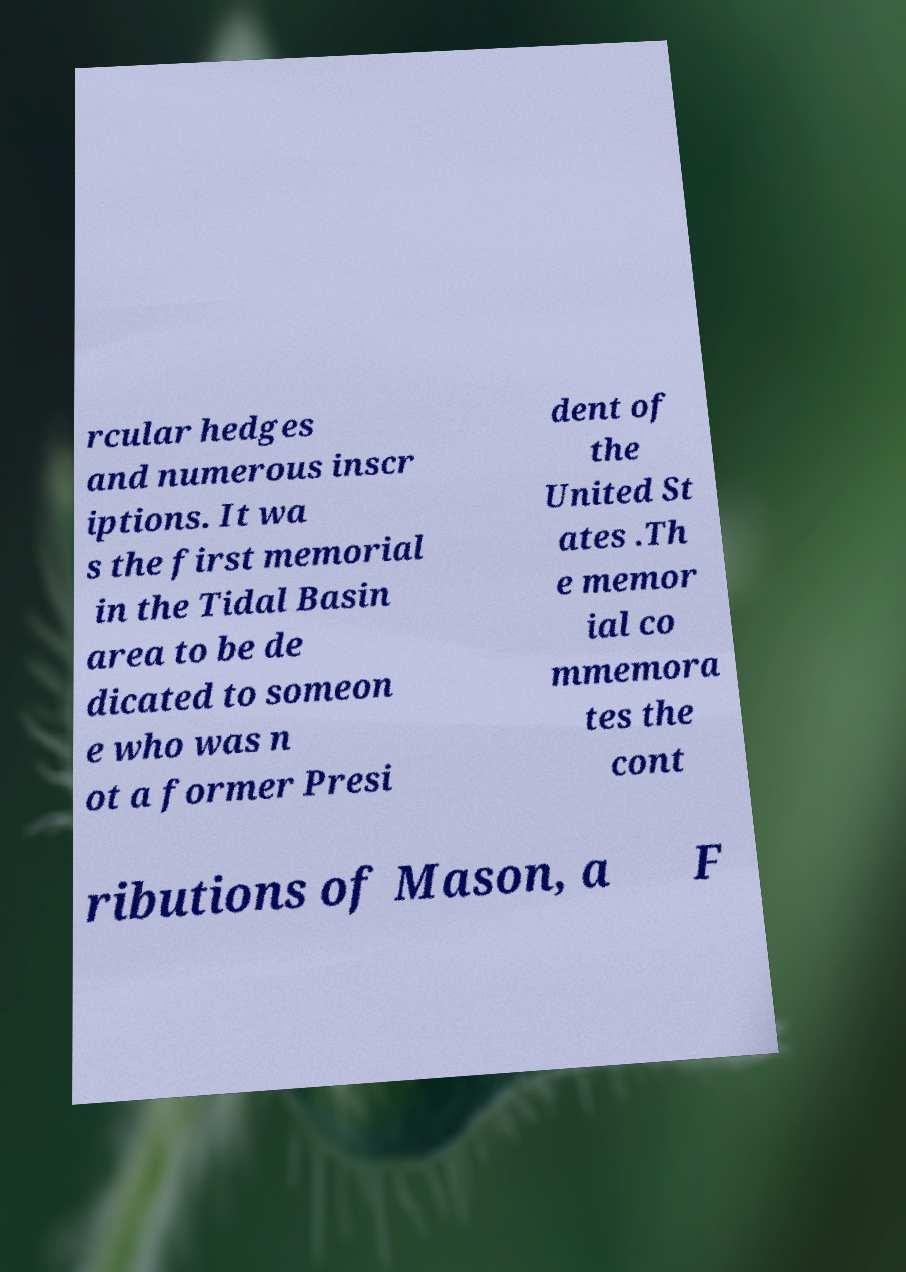Could you extract and type out the text from this image? rcular hedges and numerous inscr iptions. It wa s the first memorial in the Tidal Basin area to be de dicated to someon e who was n ot a former Presi dent of the United St ates .Th e memor ial co mmemora tes the cont ributions of Mason, a F 